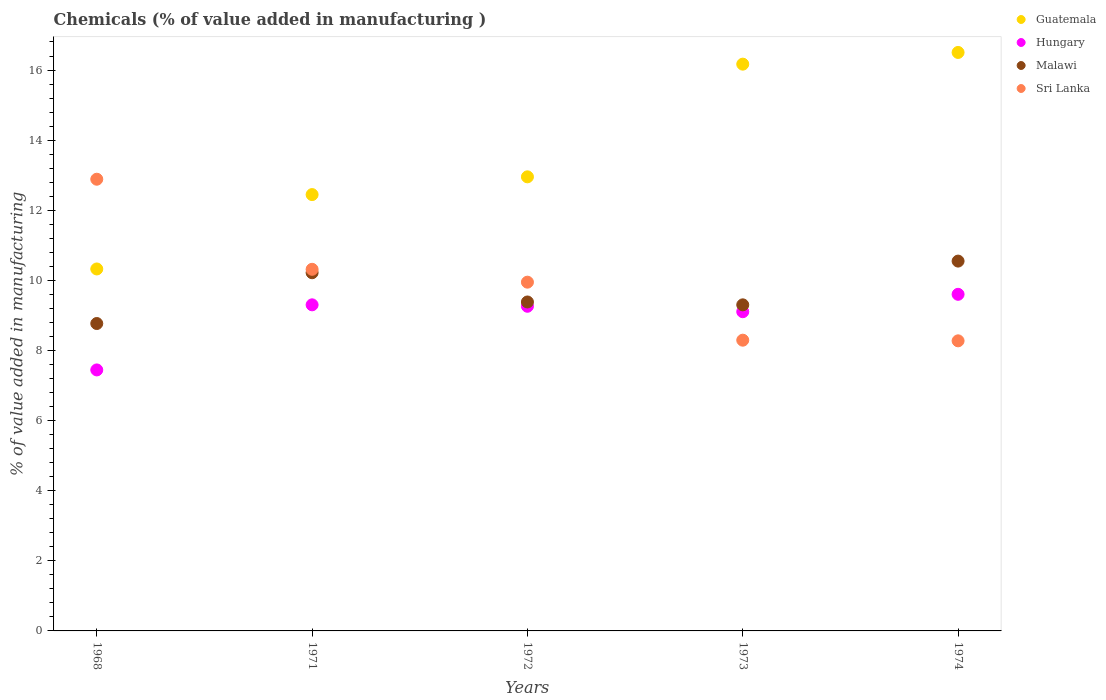What is the value added in manufacturing chemicals in Guatemala in 1968?
Provide a succinct answer. 10.33. Across all years, what is the maximum value added in manufacturing chemicals in Hungary?
Provide a short and direct response. 9.6. Across all years, what is the minimum value added in manufacturing chemicals in Sri Lanka?
Offer a terse response. 8.28. In which year was the value added in manufacturing chemicals in Sri Lanka maximum?
Offer a terse response. 1968. In which year was the value added in manufacturing chemicals in Guatemala minimum?
Make the answer very short. 1968. What is the total value added in manufacturing chemicals in Guatemala in the graph?
Your response must be concise. 68.4. What is the difference between the value added in manufacturing chemicals in Hungary in 1968 and that in 1973?
Your answer should be very brief. -1.66. What is the difference between the value added in manufacturing chemicals in Malawi in 1973 and the value added in manufacturing chemicals in Guatemala in 1972?
Provide a succinct answer. -3.65. What is the average value added in manufacturing chemicals in Hungary per year?
Keep it short and to the point. 8.94. In the year 1968, what is the difference between the value added in manufacturing chemicals in Sri Lanka and value added in manufacturing chemicals in Guatemala?
Your answer should be compact. 2.56. In how many years, is the value added in manufacturing chemicals in Hungary greater than 6.8 %?
Your answer should be compact. 5. What is the ratio of the value added in manufacturing chemicals in Malawi in 1971 to that in 1974?
Offer a very short reply. 0.97. What is the difference between the highest and the second highest value added in manufacturing chemicals in Malawi?
Offer a terse response. 0.33. What is the difference between the highest and the lowest value added in manufacturing chemicals in Guatemala?
Your response must be concise. 6.18. Is it the case that in every year, the sum of the value added in manufacturing chemicals in Sri Lanka and value added in manufacturing chemicals in Malawi  is greater than the value added in manufacturing chemicals in Guatemala?
Your answer should be compact. Yes. How many dotlines are there?
Offer a terse response. 4. How many years are there in the graph?
Your response must be concise. 5. What is the difference between two consecutive major ticks on the Y-axis?
Offer a terse response. 2. Does the graph contain any zero values?
Ensure brevity in your answer.  No. Does the graph contain grids?
Provide a succinct answer. No. Where does the legend appear in the graph?
Make the answer very short. Top right. What is the title of the graph?
Ensure brevity in your answer.  Chemicals (% of value added in manufacturing ). What is the label or title of the Y-axis?
Provide a succinct answer. % of value added in manufacturing. What is the % of value added in manufacturing in Guatemala in 1968?
Give a very brief answer. 10.33. What is the % of value added in manufacturing in Hungary in 1968?
Your response must be concise. 7.45. What is the % of value added in manufacturing of Malawi in 1968?
Give a very brief answer. 8.77. What is the % of value added in manufacturing in Sri Lanka in 1968?
Provide a short and direct response. 12.89. What is the % of value added in manufacturing of Guatemala in 1971?
Your response must be concise. 12.45. What is the % of value added in manufacturing in Hungary in 1971?
Provide a succinct answer. 9.3. What is the % of value added in manufacturing in Malawi in 1971?
Offer a terse response. 10.22. What is the % of value added in manufacturing of Sri Lanka in 1971?
Your answer should be very brief. 10.32. What is the % of value added in manufacturing in Guatemala in 1972?
Make the answer very short. 12.95. What is the % of value added in manufacturing of Hungary in 1972?
Provide a succinct answer. 9.26. What is the % of value added in manufacturing in Malawi in 1972?
Provide a short and direct response. 9.38. What is the % of value added in manufacturing in Sri Lanka in 1972?
Your answer should be compact. 9.95. What is the % of value added in manufacturing in Guatemala in 1973?
Offer a terse response. 16.17. What is the % of value added in manufacturing in Hungary in 1973?
Ensure brevity in your answer.  9.11. What is the % of value added in manufacturing in Malawi in 1973?
Provide a short and direct response. 9.3. What is the % of value added in manufacturing in Sri Lanka in 1973?
Your answer should be very brief. 8.29. What is the % of value added in manufacturing in Guatemala in 1974?
Make the answer very short. 16.5. What is the % of value added in manufacturing of Hungary in 1974?
Offer a terse response. 9.6. What is the % of value added in manufacturing in Malawi in 1974?
Your answer should be compact. 10.55. What is the % of value added in manufacturing in Sri Lanka in 1974?
Your response must be concise. 8.28. Across all years, what is the maximum % of value added in manufacturing in Guatemala?
Offer a terse response. 16.5. Across all years, what is the maximum % of value added in manufacturing in Hungary?
Offer a very short reply. 9.6. Across all years, what is the maximum % of value added in manufacturing of Malawi?
Keep it short and to the point. 10.55. Across all years, what is the maximum % of value added in manufacturing of Sri Lanka?
Your answer should be compact. 12.89. Across all years, what is the minimum % of value added in manufacturing in Guatemala?
Your response must be concise. 10.33. Across all years, what is the minimum % of value added in manufacturing of Hungary?
Keep it short and to the point. 7.45. Across all years, what is the minimum % of value added in manufacturing of Malawi?
Offer a terse response. 8.77. Across all years, what is the minimum % of value added in manufacturing of Sri Lanka?
Make the answer very short. 8.28. What is the total % of value added in manufacturing of Guatemala in the graph?
Provide a short and direct response. 68.4. What is the total % of value added in manufacturing in Hungary in the graph?
Give a very brief answer. 44.72. What is the total % of value added in manufacturing of Malawi in the graph?
Keep it short and to the point. 48.22. What is the total % of value added in manufacturing of Sri Lanka in the graph?
Your response must be concise. 49.72. What is the difference between the % of value added in manufacturing of Guatemala in 1968 and that in 1971?
Make the answer very short. -2.12. What is the difference between the % of value added in manufacturing of Hungary in 1968 and that in 1971?
Ensure brevity in your answer.  -1.86. What is the difference between the % of value added in manufacturing in Malawi in 1968 and that in 1971?
Give a very brief answer. -1.45. What is the difference between the % of value added in manufacturing in Sri Lanka in 1968 and that in 1971?
Ensure brevity in your answer.  2.57. What is the difference between the % of value added in manufacturing in Guatemala in 1968 and that in 1972?
Your answer should be very brief. -2.63. What is the difference between the % of value added in manufacturing of Hungary in 1968 and that in 1972?
Provide a short and direct response. -1.82. What is the difference between the % of value added in manufacturing in Malawi in 1968 and that in 1972?
Keep it short and to the point. -0.61. What is the difference between the % of value added in manufacturing in Sri Lanka in 1968 and that in 1972?
Ensure brevity in your answer.  2.94. What is the difference between the % of value added in manufacturing of Guatemala in 1968 and that in 1973?
Keep it short and to the point. -5.84. What is the difference between the % of value added in manufacturing of Hungary in 1968 and that in 1973?
Your answer should be compact. -1.66. What is the difference between the % of value added in manufacturing of Malawi in 1968 and that in 1973?
Provide a short and direct response. -0.53. What is the difference between the % of value added in manufacturing of Sri Lanka in 1968 and that in 1973?
Keep it short and to the point. 4.59. What is the difference between the % of value added in manufacturing of Guatemala in 1968 and that in 1974?
Give a very brief answer. -6.18. What is the difference between the % of value added in manufacturing of Hungary in 1968 and that in 1974?
Provide a succinct answer. -2.16. What is the difference between the % of value added in manufacturing in Malawi in 1968 and that in 1974?
Keep it short and to the point. -1.78. What is the difference between the % of value added in manufacturing in Sri Lanka in 1968 and that in 1974?
Provide a short and direct response. 4.61. What is the difference between the % of value added in manufacturing in Guatemala in 1971 and that in 1972?
Give a very brief answer. -0.51. What is the difference between the % of value added in manufacturing of Hungary in 1971 and that in 1972?
Your answer should be compact. 0.04. What is the difference between the % of value added in manufacturing of Malawi in 1971 and that in 1972?
Offer a very short reply. 0.83. What is the difference between the % of value added in manufacturing of Sri Lanka in 1971 and that in 1972?
Make the answer very short. 0.37. What is the difference between the % of value added in manufacturing of Guatemala in 1971 and that in 1973?
Provide a succinct answer. -3.72. What is the difference between the % of value added in manufacturing of Hungary in 1971 and that in 1973?
Provide a succinct answer. 0.2. What is the difference between the % of value added in manufacturing in Malawi in 1971 and that in 1973?
Your answer should be compact. 0.92. What is the difference between the % of value added in manufacturing of Sri Lanka in 1971 and that in 1973?
Your response must be concise. 2.02. What is the difference between the % of value added in manufacturing of Guatemala in 1971 and that in 1974?
Your answer should be very brief. -4.05. What is the difference between the % of value added in manufacturing of Hungary in 1971 and that in 1974?
Ensure brevity in your answer.  -0.3. What is the difference between the % of value added in manufacturing of Malawi in 1971 and that in 1974?
Your answer should be very brief. -0.33. What is the difference between the % of value added in manufacturing of Sri Lanka in 1971 and that in 1974?
Your answer should be compact. 2.04. What is the difference between the % of value added in manufacturing in Guatemala in 1972 and that in 1973?
Provide a short and direct response. -3.21. What is the difference between the % of value added in manufacturing of Hungary in 1972 and that in 1973?
Your answer should be very brief. 0.16. What is the difference between the % of value added in manufacturing of Malawi in 1972 and that in 1973?
Your response must be concise. 0.08. What is the difference between the % of value added in manufacturing in Sri Lanka in 1972 and that in 1973?
Ensure brevity in your answer.  1.66. What is the difference between the % of value added in manufacturing in Guatemala in 1972 and that in 1974?
Your answer should be compact. -3.55. What is the difference between the % of value added in manufacturing in Hungary in 1972 and that in 1974?
Provide a short and direct response. -0.34. What is the difference between the % of value added in manufacturing of Malawi in 1972 and that in 1974?
Your response must be concise. -1.17. What is the difference between the % of value added in manufacturing of Sri Lanka in 1972 and that in 1974?
Provide a succinct answer. 1.67. What is the difference between the % of value added in manufacturing of Guatemala in 1973 and that in 1974?
Give a very brief answer. -0.33. What is the difference between the % of value added in manufacturing in Hungary in 1973 and that in 1974?
Provide a short and direct response. -0.5. What is the difference between the % of value added in manufacturing of Malawi in 1973 and that in 1974?
Provide a succinct answer. -1.25. What is the difference between the % of value added in manufacturing of Sri Lanka in 1973 and that in 1974?
Provide a succinct answer. 0.02. What is the difference between the % of value added in manufacturing of Guatemala in 1968 and the % of value added in manufacturing of Hungary in 1971?
Offer a terse response. 1.02. What is the difference between the % of value added in manufacturing of Guatemala in 1968 and the % of value added in manufacturing of Malawi in 1971?
Ensure brevity in your answer.  0.11. What is the difference between the % of value added in manufacturing of Guatemala in 1968 and the % of value added in manufacturing of Sri Lanka in 1971?
Your answer should be very brief. 0.01. What is the difference between the % of value added in manufacturing of Hungary in 1968 and the % of value added in manufacturing of Malawi in 1971?
Offer a very short reply. -2.77. What is the difference between the % of value added in manufacturing of Hungary in 1968 and the % of value added in manufacturing of Sri Lanka in 1971?
Provide a short and direct response. -2.87. What is the difference between the % of value added in manufacturing in Malawi in 1968 and the % of value added in manufacturing in Sri Lanka in 1971?
Provide a succinct answer. -1.55. What is the difference between the % of value added in manufacturing of Guatemala in 1968 and the % of value added in manufacturing of Hungary in 1972?
Make the answer very short. 1.06. What is the difference between the % of value added in manufacturing in Guatemala in 1968 and the % of value added in manufacturing in Malawi in 1972?
Make the answer very short. 0.94. What is the difference between the % of value added in manufacturing of Guatemala in 1968 and the % of value added in manufacturing of Sri Lanka in 1972?
Offer a terse response. 0.38. What is the difference between the % of value added in manufacturing in Hungary in 1968 and the % of value added in manufacturing in Malawi in 1972?
Ensure brevity in your answer.  -1.94. What is the difference between the % of value added in manufacturing of Hungary in 1968 and the % of value added in manufacturing of Sri Lanka in 1972?
Provide a short and direct response. -2.5. What is the difference between the % of value added in manufacturing in Malawi in 1968 and the % of value added in manufacturing in Sri Lanka in 1972?
Make the answer very short. -1.18. What is the difference between the % of value added in manufacturing in Guatemala in 1968 and the % of value added in manufacturing in Hungary in 1973?
Give a very brief answer. 1.22. What is the difference between the % of value added in manufacturing in Guatemala in 1968 and the % of value added in manufacturing in Malawi in 1973?
Your answer should be compact. 1.02. What is the difference between the % of value added in manufacturing of Guatemala in 1968 and the % of value added in manufacturing of Sri Lanka in 1973?
Offer a very short reply. 2.03. What is the difference between the % of value added in manufacturing in Hungary in 1968 and the % of value added in manufacturing in Malawi in 1973?
Offer a terse response. -1.86. What is the difference between the % of value added in manufacturing in Hungary in 1968 and the % of value added in manufacturing in Sri Lanka in 1973?
Your answer should be very brief. -0.85. What is the difference between the % of value added in manufacturing of Malawi in 1968 and the % of value added in manufacturing of Sri Lanka in 1973?
Your answer should be very brief. 0.48. What is the difference between the % of value added in manufacturing of Guatemala in 1968 and the % of value added in manufacturing of Hungary in 1974?
Ensure brevity in your answer.  0.72. What is the difference between the % of value added in manufacturing of Guatemala in 1968 and the % of value added in manufacturing of Malawi in 1974?
Offer a terse response. -0.22. What is the difference between the % of value added in manufacturing in Guatemala in 1968 and the % of value added in manufacturing in Sri Lanka in 1974?
Offer a terse response. 2.05. What is the difference between the % of value added in manufacturing of Hungary in 1968 and the % of value added in manufacturing of Malawi in 1974?
Offer a very short reply. -3.1. What is the difference between the % of value added in manufacturing of Hungary in 1968 and the % of value added in manufacturing of Sri Lanka in 1974?
Your answer should be very brief. -0.83. What is the difference between the % of value added in manufacturing in Malawi in 1968 and the % of value added in manufacturing in Sri Lanka in 1974?
Keep it short and to the point. 0.49. What is the difference between the % of value added in manufacturing in Guatemala in 1971 and the % of value added in manufacturing in Hungary in 1972?
Keep it short and to the point. 3.19. What is the difference between the % of value added in manufacturing in Guatemala in 1971 and the % of value added in manufacturing in Malawi in 1972?
Offer a terse response. 3.06. What is the difference between the % of value added in manufacturing of Guatemala in 1971 and the % of value added in manufacturing of Sri Lanka in 1972?
Your answer should be compact. 2.5. What is the difference between the % of value added in manufacturing in Hungary in 1971 and the % of value added in manufacturing in Malawi in 1972?
Provide a short and direct response. -0.08. What is the difference between the % of value added in manufacturing in Hungary in 1971 and the % of value added in manufacturing in Sri Lanka in 1972?
Your response must be concise. -0.65. What is the difference between the % of value added in manufacturing in Malawi in 1971 and the % of value added in manufacturing in Sri Lanka in 1972?
Make the answer very short. 0.27. What is the difference between the % of value added in manufacturing of Guatemala in 1971 and the % of value added in manufacturing of Hungary in 1973?
Your answer should be very brief. 3.34. What is the difference between the % of value added in manufacturing in Guatemala in 1971 and the % of value added in manufacturing in Malawi in 1973?
Offer a terse response. 3.15. What is the difference between the % of value added in manufacturing in Guatemala in 1971 and the % of value added in manufacturing in Sri Lanka in 1973?
Make the answer very short. 4.15. What is the difference between the % of value added in manufacturing of Hungary in 1971 and the % of value added in manufacturing of Sri Lanka in 1973?
Provide a short and direct response. 1.01. What is the difference between the % of value added in manufacturing of Malawi in 1971 and the % of value added in manufacturing of Sri Lanka in 1973?
Give a very brief answer. 1.92. What is the difference between the % of value added in manufacturing of Guatemala in 1971 and the % of value added in manufacturing of Hungary in 1974?
Keep it short and to the point. 2.84. What is the difference between the % of value added in manufacturing of Guatemala in 1971 and the % of value added in manufacturing of Malawi in 1974?
Your answer should be compact. 1.9. What is the difference between the % of value added in manufacturing of Guatemala in 1971 and the % of value added in manufacturing of Sri Lanka in 1974?
Your answer should be compact. 4.17. What is the difference between the % of value added in manufacturing of Hungary in 1971 and the % of value added in manufacturing of Malawi in 1974?
Keep it short and to the point. -1.25. What is the difference between the % of value added in manufacturing of Hungary in 1971 and the % of value added in manufacturing of Sri Lanka in 1974?
Keep it short and to the point. 1.03. What is the difference between the % of value added in manufacturing of Malawi in 1971 and the % of value added in manufacturing of Sri Lanka in 1974?
Offer a terse response. 1.94. What is the difference between the % of value added in manufacturing in Guatemala in 1972 and the % of value added in manufacturing in Hungary in 1973?
Your answer should be very brief. 3.85. What is the difference between the % of value added in manufacturing in Guatemala in 1972 and the % of value added in manufacturing in Malawi in 1973?
Give a very brief answer. 3.65. What is the difference between the % of value added in manufacturing of Guatemala in 1972 and the % of value added in manufacturing of Sri Lanka in 1973?
Your answer should be very brief. 4.66. What is the difference between the % of value added in manufacturing of Hungary in 1972 and the % of value added in manufacturing of Malawi in 1973?
Your answer should be very brief. -0.04. What is the difference between the % of value added in manufacturing in Hungary in 1972 and the % of value added in manufacturing in Sri Lanka in 1973?
Provide a short and direct response. 0.97. What is the difference between the % of value added in manufacturing of Malawi in 1972 and the % of value added in manufacturing of Sri Lanka in 1973?
Offer a very short reply. 1.09. What is the difference between the % of value added in manufacturing in Guatemala in 1972 and the % of value added in manufacturing in Hungary in 1974?
Offer a very short reply. 3.35. What is the difference between the % of value added in manufacturing of Guatemala in 1972 and the % of value added in manufacturing of Malawi in 1974?
Your answer should be compact. 2.4. What is the difference between the % of value added in manufacturing in Guatemala in 1972 and the % of value added in manufacturing in Sri Lanka in 1974?
Make the answer very short. 4.68. What is the difference between the % of value added in manufacturing in Hungary in 1972 and the % of value added in manufacturing in Malawi in 1974?
Make the answer very short. -1.29. What is the difference between the % of value added in manufacturing of Hungary in 1972 and the % of value added in manufacturing of Sri Lanka in 1974?
Your response must be concise. 0.99. What is the difference between the % of value added in manufacturing of Malawi in 1972 and the % of value added in manufacturing of Sri Lanka in 1974?
Provide a short and direct response. 1.11. What is the difference between the % of value added in manufacturing of Guatemala in 1973 and the % of value added in manufacturing of Hungary in 1974?
Your answer should be very brief. 6.57. What is the difference between the % of value added in manufacturing in Guatemala in 1973 and the % of value added in manufacturing in Malawi in 1974?
Provide a short and direct response. 5.62. What is the difference between the % of value added in manufacturing of Guatemala in 1973 and the % of value added in manufacturing of Sri Lanka in 1974?
Ensure brevity in your answer.  7.89. What is the difference between the % of value added in manufacturing in Hungary in 1973 and the % of value added in manufacturing in Malawi in 1974?
Your answer should be compact. -1.44. What is the difference between the % of value added in manufacturing in Hungary in 1973 and the % of value added in manufacturing in Sri Lanka in 1974?
Provide a succinct answer. 0.83. What is the difference between the % of value added in manufacturing in Malawi in 1973 and the % of value added in manufacturing in Sri Lanka in 1974?
Provide a short and direct response. 1.03. What is the average % of value added in manufacturing of Guatemala per year?
Give a very brief answer. 13.68. What is the average % of value added in manufacturing of Hungary per year?
Your answer should be very brief. 8.94. What is the average % of value added in manufacturing in Malawi per year?
Offer a very short reply. 9.64. What is the average % of value added in manufacturing in Sri Lanka per year?
Offer a terse response. 9.94. In the year 1968, what is the difference between the % of value added in manufacturing in Guatemala and % of value added in manufacturing in Hungary?
Provide a short and direct response. 2.88. In the year 1968, what is the difference between the % of value added in manufacturing in Guatemala and % of value added in manufacturing in Malawi?
Your answer should be compact. 1.56. In the year 1968, what is the difference between the % of value added in manufacturing of Guatemala and % of value added in manufacturing of Sri Lanka?
Make the answer very short. -2.56. In the year 1968, what is the difference between the % of value added in manufacturing of Hungary and % of value added in manufacturing of Malawi?
Your response must be concise. -1.32. In the year 1968, what is the difference between the % of value added in manufacturing of Hungary and % of value added in manufacturing of Sri Lanka?
Your answer should be very brief. -5.44. In the year 1968, what is the difference between the % of value added in manufacturing of Malawi and % of value added in manufacturing of Sri Lanka?
Offer a terse response. -4.12. In the year 1971, what is the difference between the % of value added in manufacturing in Guatemala and % of value added in manufacturing in Hungary?
Keep it short and to the point. 3.14. In the year 1971, what is the difference between the % of value added in manufacturing of Guatemala and % of value added in manufacturing of Malawi?
Offer a terse response. 2.23. In the year 1971, what is the difference between the % of value added in manufacturing of Guatemala and % of value added in manufacturing of Sri Lanka?
Offer a very short reply. 2.13. In the year 1971, what is the difference between the % of value added in manufacturing in Hungary and % of value added in manufacturing in Malawi?
Your answer should be compact. -0.92. In the year 1971, what is the difference between the % of value added in manufacturing of Hungary and % of value added in manufacturing of Sri Lanka?
Offer a very short reply. -1.01. In the year 1971, what is the difference between the % of value added in manufacturing in Malawi and % of value added in manufacturing in Sri Lanka?
Offer a terse response. -0.1. In the year 1972, what is the difference between the % of value added in manufacturing in Guatemala and % of value added in manufacturing in Hungary?
Provide a succinct answer. 3.69. In the year 1972, what is the difference between the % of value added in manufacturing of Guatemala and % of value added in manufacturing of Malawi?
Give a very brief answer. 3.57. In the year 1972, what is the difference between the % of value added in manufacturing in Guatemala and % of value added in manufacturing in Sri Lanka?
Your answer should be very brief. 3. In the year 1972, what is the difference between the % of value added in manufacturing of Hungary and % of value added in manufacturing of Malawi?
Provide a short and direct response. -0.12. In the year 1972, what is the difference between the % of value added in manufacturing of Hungary and % of value added in manufacturing of Sri Lanka?
Make the answer very short. -0.69. In the year 1972, what is the difference between the % of value added in manufacturing of Malawi and % of value added in manufacturing of Sri Lanka?
Your answer should be compact. -0.56. In the year 1973, what is the difference between the % of value added in manufacturing in Guatemala and % of value added in manufacturing in Hungary?
Ensure brevity in your answer.  7.06. In the year 1973, what is the difference between the % of value added in manufacturing in Guatemala and % of value added in manufacturing in Malawi?
Your answer should be compact. 6.87. In the year 1973, what is the difference between the % of value added in manufacturing of Guatemala and % of value added in manufacturing of Sri Lanka?
Provide a succinct answer. 7.87. In the year 1973, what is the difference between the % of value added in manufacturing of Hungary and % of value added in manufacturing of Malawi?
Your answer should be very brief. -0.2. In the year 1973, what is the difference between the % of value added in manufacturing of Hungary and % of value added in manufacturing of Sri Lanka?
Your answer should be compact. 0.81. In the year 1973, what is the difference between the % of value added in manufacturing in Malawi and % of value added in manufacturing in Sri Lanka?
Your response must be concise. 1.01. In the year 1974, what is the difference between the % of value added in manufacturing of Guatemala and % of value added in manufacturing of Hungary?
Offer a terse response. 6.9. In the year 1974, what is the difference between the % of value added in manufacturing of Guatemala and % of value added in manufacturing of Malawi?
Your answer should be very brief. 5.95. In the year 1974, what is the difference between the % of value added in manufacturing in Guatemala and % of value added in manufacturing in Sri Lanka?
Keep it short and to the point. 8.23. In the year 1974, what is the difference between the % of value added in manufacturing in Hungary and % of value added in manufacturing in Malawi?
Keep it short and to the point. -0.95. In the year 1974, what is the difference between the % of value added in manufacturing of Hungary and % of value added in manufacturing of Sri Lanka?
Keep it short and to the point. 1.33. In the year 1974, what is the difference between the % of value added in manufacturing in Malawi and % of value added in manufacturing in Sri Lanka?
Offer a very short reply. 2.27. What is the ratio of the % of value added in manufacturing in Guatemala in 1968 to that in 1971?
Provide a succinct answer. 0.83. What is the ratio of the % of value added in manufacturing of Hungary in 1968 to that in 1971?
Give a very brief answer. 0.8. What is the ratio of the % of value added in manufacturing of Malawi in 1968 to that in 1971?
Offer a very short reply. 0.86. What is the ratio of the % of value added in manufacturing in Sri Lanka in 1968 to that in 1971?
Make the answer very short. 1.25. What is the ratio of the % of value added in manufacturing in Guatemala in 1968 to that in 1972?
Keep it short and to the point. 0.8. What is the ratio of the % of value added in manufacturing in Hungary in 1968 to that in 1972?
Your response must be concise. 0.8. What is the ratio of the % of value added in manufacturing of Malawi in 1968 to that in 1972?
Your answer should be compact. 0.93. What is the ratio of the % of value added in manufacturing in Sri Lanka in 1968 to that in 1972?
Ensure brevity in your answer.  1.3. What is the ratio of the % of value added in manufacturing of Guatemala in 1968 to that in 1973?
Offer a terse response. 0.64. What is the ratio of the % of value added in manufacturing in Hungary in 1968 to that in 1973?
Make the answer very short. 0.82. What is the ratio of the % of value added in manufacturing in Malawi in 1968 to that in 1973?
Give a very brief answer. 0.94. What is the ratio of the % of value added in manufacturing in Sri Lanka in 1968 to that in 1973?
Make the answer very short. 1.55. What is the ratio of the % of value added in manufacturing in Guatemala in 1968 to that in 1974?
Provide a succinct answer. 0.63. What is the ratio of the % of value added in manufacturing in Hungary in 1968 to that in 1974?
Keep it short and to the point. 0.78. What is the ratio of the % of value added in manufacturing in Malawi in 1968 to that in 1974?
Ensure brevity in your answer.  0.83. What is the ratio of the % of value added in manufacturing of Sri Lanka in 1968 to that in 1974?
Offer a terse response. 1.56. What is the ratio of the % of value added in manufacturing in Guatemala in 1971 to that in 1972?
Your response must be concise. 0.96. What is the ratio of the % of value added in manufacturing in Malawi in 1971 to that in 1972?
Offer a very short reply. 1.09. What is the ratio of the % of value added in manufacturing of Sri Lanka in 1971 to that in 1972?
Make the answer very short. 1.04. What is the ratio of the % of value added in manufacturing in Guatemala in 1971 to that in 1973?
Offer a terse response. 0.77. What is the ratio of the % of value added in manufacturing in Hungary in 1971 to that in 1973?
Keep it short and to the point. 1.02. What is the ratio of the % of value added in manufacturing of Malawi in 1971 to that in 1973?
Offer a very short reply. 1.1. What is the ratio of the % of value added in manufacturing of Sri Lanka in 1971 to that in 1973?
Give a very brief answer. 1.24. What is the ratio of the % of value added in manufacturing of Guatemala in 1971 to that in 1974?
Give a very brief answer. 0.75. What is the ratio of the % of value added in manufacturing of Hungary in 1971 to that in 1974?
Offer a very short reply. 0.97. What is the ratio of the % of value added in manufacturing in Malawi in 1971 to that in 1974?
Ensure brevity in your answer.  0.97. What is the ratio of the % of value added in manufacturing in Sri Lanka in 1971 to that in 1974?
Make the answer very short. 1.25. What is the ratio of the % of value added in manufacturing of Guatemala in 1972 to that in 1973?
Your response must be concise. 0.8. What is the ratio of the % of value added in manufacturing in Hungary in 1972 to that in 1973?
Offer a very short reply. 1.02. What is the ratio of the % of value added in manufacturing of Malawi in 1972 to that in 1973?
Your answer should be very brief. 1.01. What is the ratio of the % of value added in manufacturing in Sri Lanka in 1972 to that in 1973?
Keep it short and to the point. 1.2. What is the ratio of the % of value added in manufacturing in Guatemala in 1972 to that in 1974?
Offer a terse response. 0.79. What is the ratio of the % of value added in manufacturing of Hungary in 1972 to that in 1974?
Offer a very short reply. 0.96. What is the ratio of the % of value added in manufacturing in Malawi in 1972 to that in 1974?
Your answer should be compact. 0.89. What is the ratio of the % of value added in manufacturing in Sri Lanka in 1972 to that in 1974?
Your answer should be very brief. 1.2. What is the ratio of the % of value added in manufacturing in Guatemala in 1973 to that in 1974?
Your response must be concise. 0.98. What is the ratio of the % of value added in manufacturing of Hungary in 1973 to that in 1974?
Give a very brief answer. 0.95. What is the ratio of the % of value added in manufacturing of Malawi in 1973 to that in 1974?
Provide a succinct answer. 0.88. What is the difference between the highest and the second highest % of value added in manufacturing in Guatemala?
Offer a terse response. 0.33. What is the difference between the highest and the second highest % of value added in manufacturing of Malawi?
Give a very brief answer. 0.33. What is the difference between the highest and the second highest % of value added in manufacturing of Sri Lanka?
Ensure brevity in your answer.  2.57. What is the difference between the highest and the lowest % of value added in manufacturing in Guatemala?
Your answer should be compact. 6.18. What is the difference between the highest and the lowest % of value added in manufacturing in Hungary?
Offer a terse response. 2.16. What is the difference between the highest and the lowest % of value added in manufacturing of Malawi?
Ensure brevity in your answer.  1.78. What is the difference between the highest and the lowest % of value added in manufacturing of Sri Lanka?
Your answer should be compact. 4.61. 